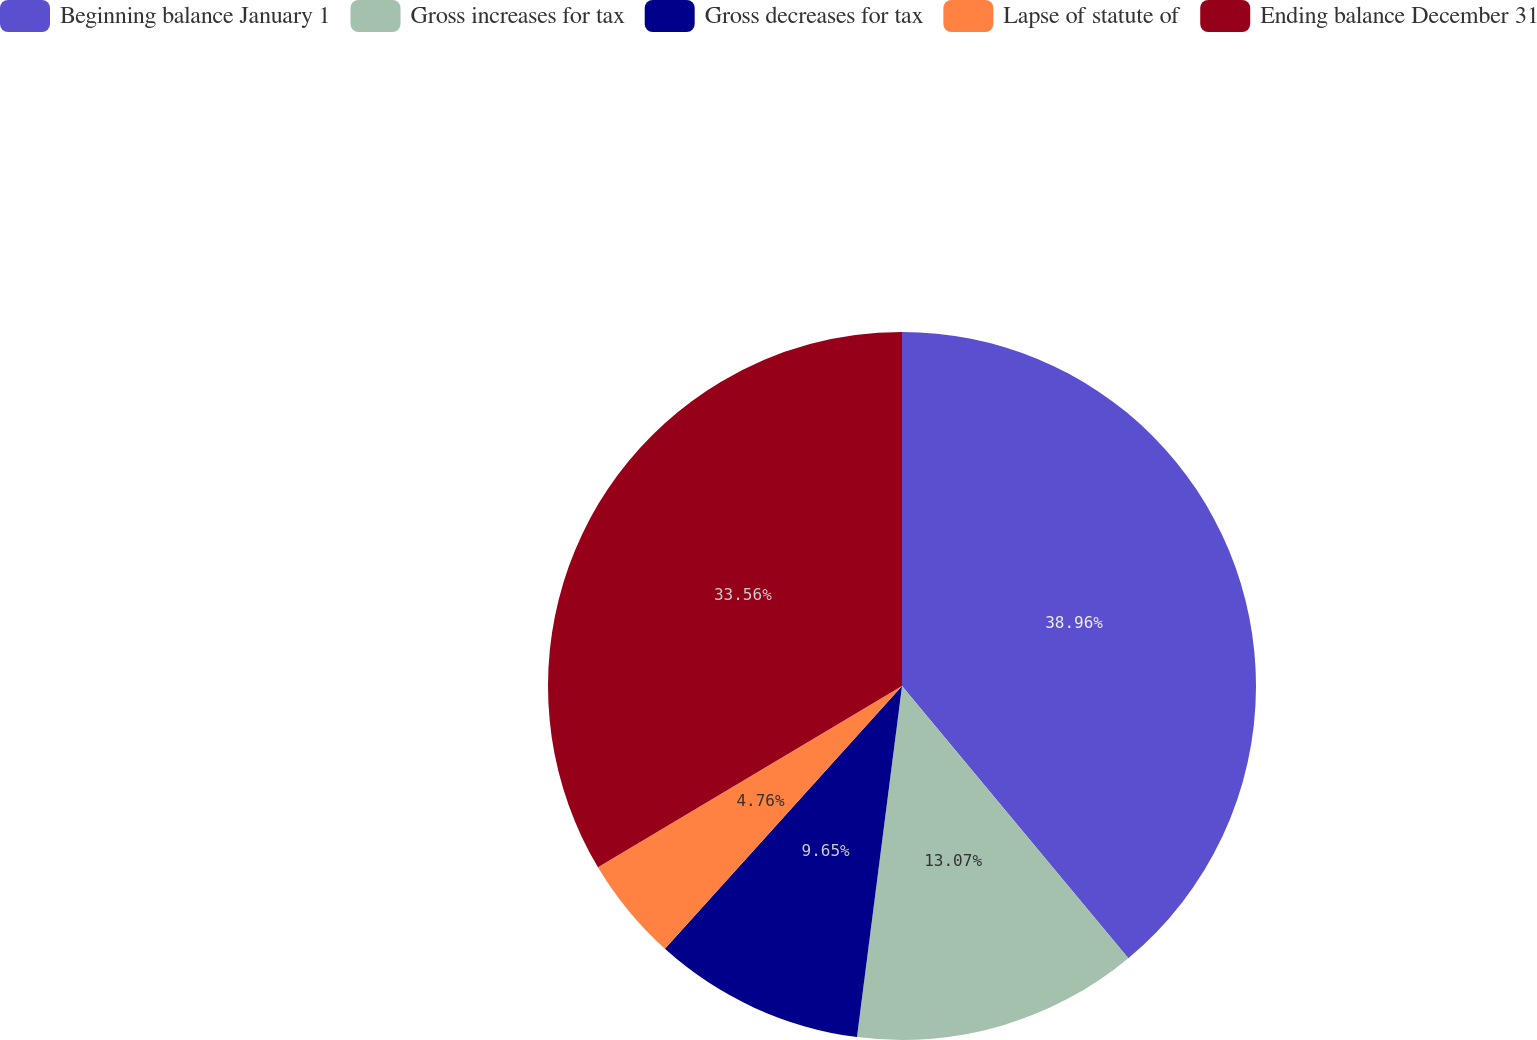Convert chart to OTSL. <chart><loc_0><loc_0><loc_500><loc_500><pie_chart><fcel>Beginning balance January 1<fcel>Gross increases for tax<fcel>Gross decreases for tax<fcel>Lapse of statute of<fcel>Ending balance December 31<nl><fcel>38.96%<fcel>13.07%<fcel>9.65%<fcel>4.76%<fcel>33.56%<nl></chart> 